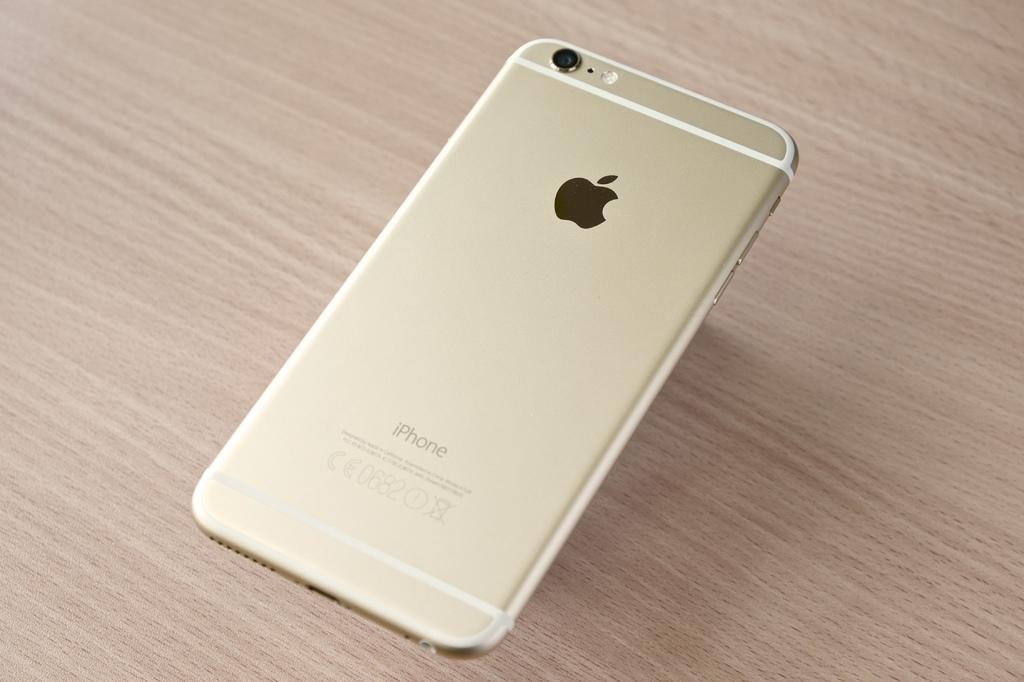<image>
Relay a brief, clear account of the picture shown. A apple iphone upside down on a table 